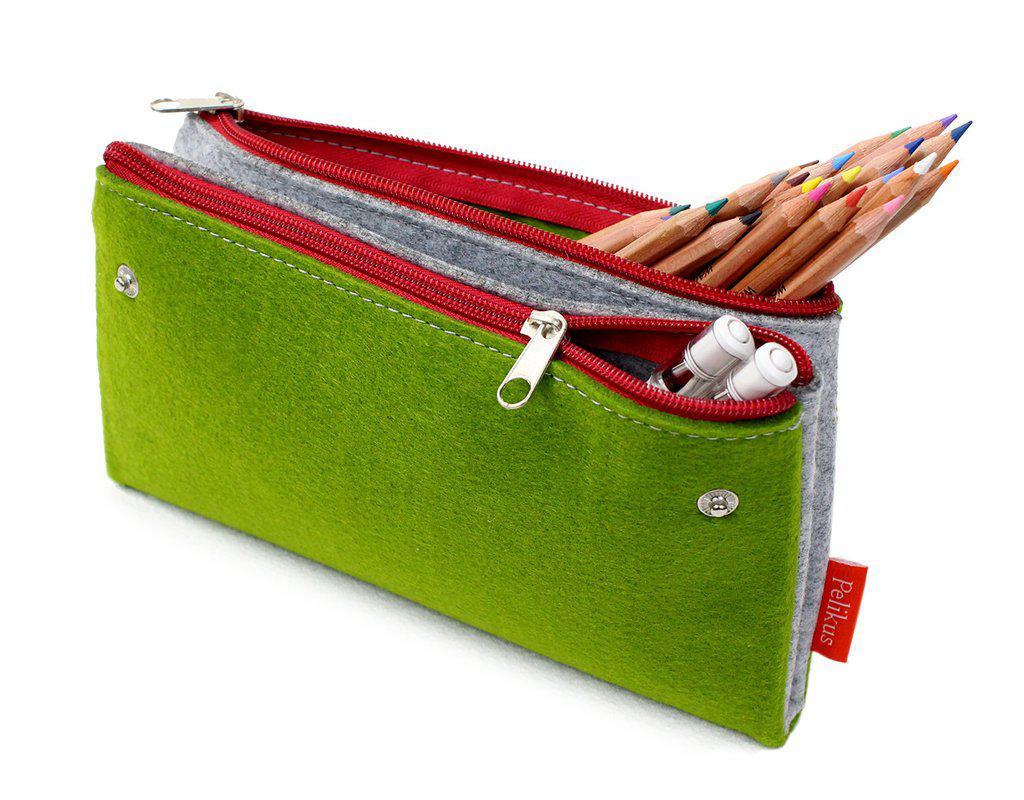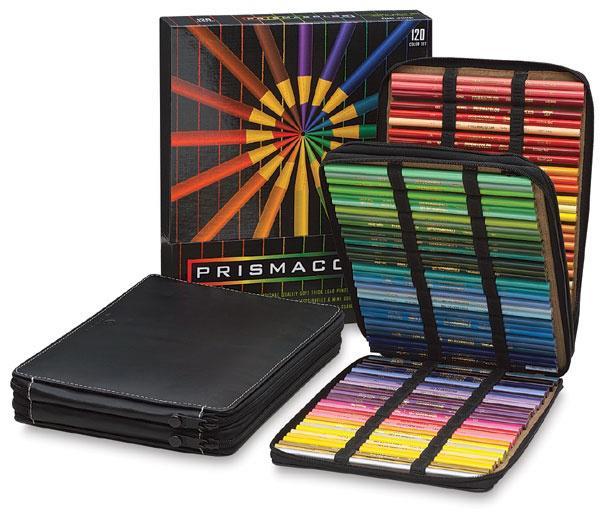The first image is the image on the left, the second image is the image on the right. Examine the images to the left and right. Is the description "One image features a pencil case style with red zipper and green and gray color scheme, and the other image includes various rainbow colors on something black." accurate? Answer yes or no. Yes. The first image is the image on the left, the second image is the image on the right. Evaluate the accuracy of this statement regarding the images: "An image contains at least one green pencil bag with a red zipper.". Is it true? Answer yes or no. Yes. 